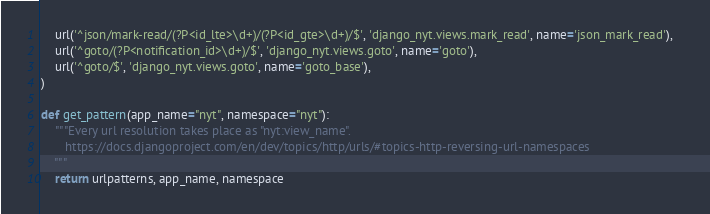<code> <loc_0><loc_0><loc_500><loc_500><_Python_>    url('^json/mark-read/(?P<id_lte>\d+)/(?P<id_gte>\d+)/$', 'django_nyt.views.mark_read', name='json_mark_read'),   
    url('^goto/(?P<notification_id>\d+)/$', 'django_nyt.views.goto', name='goto'),   
    url('^goto/$', 'django_nyt.views.goto', name='goto_base'),   
)

def get_pattern(app_name="nyt", namespace="nyt"):
    """Every url resolution takes place as "nyt:view_name".
       https://docs.djangoproject.com/en/dev/topics/http/urls/#topics-http-reversing-url-namespaces
    """
    return urlpatterns, app_name, namespace</code> 